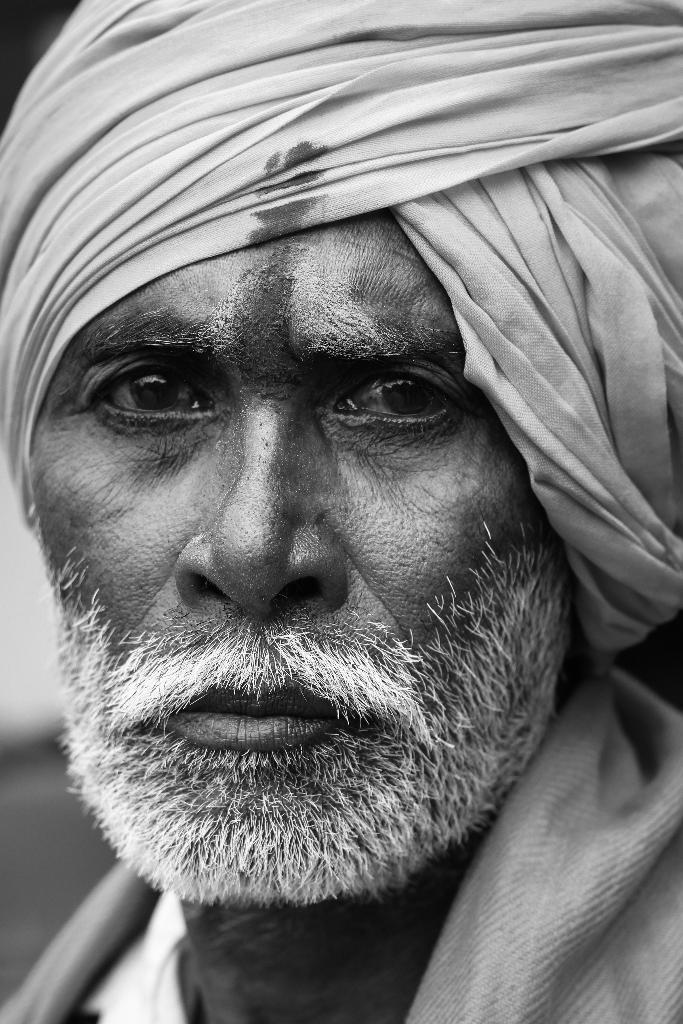Could you give a brief overview of what you see in this image? This picture is a black and white image. In this image we can see one man with white bread. 